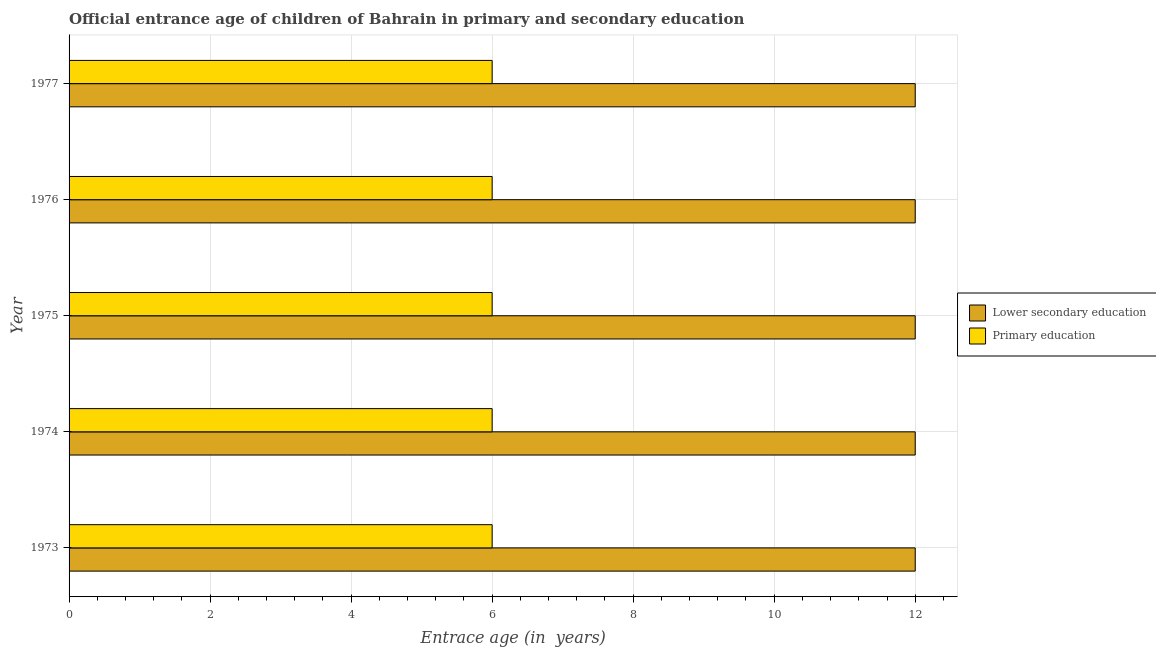How many groups of bars are there?
Your answer should be very brief. 5. Are the number of bars per tick equal to the number of legend labels?
Your response must be concise. Yes. Are the number of bars on each tick of the Y-axis equal?
Make the answer very short. Yes. How many bars are there on the 4th tick from the top?
Give a very brief answer. 2. How many bars are there on the 1st tick from the bottom?
Give a very brief answer. 2. What is the label of the 5th group of bars from the top?
Your answer should be very brief. 1973. Across all years, what is the maximum entrance age of children in lower secondary education?
Offer a terse response. 12. Across all years, what is the minimum entrance age of children in lower secondary education?
Offer a very short reply. 12. In which year was the entrance age of chiildren in primary education minimum?
Your response must be concise. 1973. What is the total entrance age of children in lower secondary education in the graph?
Your answer should be very brief. 60. What is the difference between the entrance age of children in lower secondary education in 1976 and the entrance age of chiildren in primary education in 1974?
Provide a succinct answer. 6. In the year 1974, what is the difference between the entrance age of chiildren in primary education and entrance age of children in lower secondary education?
Your answer should be very brief. -6. What is the ratio of the entrance age of chiildren in primary education in 1974 to that in 1977?
Offer a terse response. 1. Is the entrance age of chiildren in primary education in 1975 less than that in 1976?
Offer a very short reply. No. Is the difference between the entrance age of children in lower secondary education in 1973 and 1976 greater than the difference between the entrance age of chiildren in primary education in 1973 and 1976?
Provide a succinct answer. No. In how many years, is the entrance age of children in lower secondary education greater than the average entrance age of children in lower secondary education taken over all years?
Keep it short and to the point. 0. Is the sum of the entrance age of children in lower secondary education in 1975 and 1976 greater than the maximum entrance age of chiildren in primary education across all years?
Your answer should be compact. Yes. What does the 2nd bar from the top in 1974 represents?
Offer a very short reply. Lower secondary education. What does the 1st bar from the bottom in 1977 represents?
Provide a short and direct response. Lower secondary education. Are all the bars in the graph horizontal?
Offer a terse response. Yes. Where does the legend appear in the graph?
Your response must be concise. Center right. What is the title of the graph?
Offer a terse response. Official entrance age of children of Bahrain in primary and secondary education. Does "Methane" appear as one of the legend labels in the graph?
Offer a very short reply. No. What is the label or title of the X-axis?
Keep it short and to the point. Entrace age (in  years). What is the label or title of the Y-axis?
Your answer should be compact. Year. What is the Entrace age (in  years) of Lower secondary education in 1973?
Offer a terse response. 12. What is the Entrace age (in  years) of Primary education in 1973?
Offer a terse response. 6. What is the Entrace age (in  years) in Lower secondary education in 1974?
Your answer should be very brief. 12. What is the Entrace age (in  years) in Lower secondary education in 1975?
Offer a terse response. 12. What is the Entrace age (in  years) in Primary education in 1976?
Provide a succinct answer. 6. What is the Entrace age (in  years) in Primary education in 1977?
Provide a succinct answer. 6. What is the total Entrace age (in  years) of Primary education in the graph?
Keep it short and to the point. 30. What is the difference between the Entrace age (in  years) in Lower secondary education in 1973 and that in 1974?
Ensure brevity in your answer.  0. What is the difference between the Entrace age (in  years) in Primary education in 1973 and that in 1975?
Your answer should be very brief. 0. What is the difference between the Entrace age (in  years) of Primary education in 1973 and that in 1976?
Your answer should be compact. 0. What is the difference between the Entrace age (in  years) in Lower secondary education in 1973 and that in 1977?
Keep it short and to the point. 0. What is the difference between the Entrace age (in  years) of Primary education in 1974 and that in 1975?
Give a very brief answer. 0. What is the difference between the Entrace age (in  years) in Primary education in 1974 and that in 1977?
Your answer should be compact. 0. What is the difference between the Entrace age (in  years) of Primary education in 1975 and that in 1976?
Keep it short and to the point. 0. What is the difference between the Entrace age (in  years) of Lower secondary education in 1975 and that in 1977?
Offer a terse response. 0. What is the difference between the Entrace age (in  years) in Primary education in 1975 and that in 1977?
Your response must be concise. 0. What is the difference between the Entrace age (in  years) in Primary education in 1976 and that in 1977?
Provide a short and direct response. 0. What is the difference between the Entrace age (in  years) in Lower secondary education in 1973 and the Entrace age (in  years) in Primary education in 1974?
Provide a succinct answer. 6. What is the difference between the Entrace age (in  years) of Lower secondary education in 1973 and the Entrace age (in  years) of Primary education in 1976?
Provide a succinct answer. 6. What is the difference between the Entrace age (in  years) of Lower secondary education in 1973 and the Entrace age (in  years) of Primary education in 1977?
Ensure brevity in your answer.  6. What is the difference between the Entrace age (in  years) in Lower secondary education in 1974 and the Entrace age (in  years) in Primary education in 1975?
Your answer should be very brief. 6. What is the difference between the Entrace age (in  years) in Lower secondary education in 1974 and the Entrace age (in  years) in Primary education in 1977?
Provide a succinct answer. 6. What is the difference between the Entrace age (in  years) of Lower secondary education in 1975 and the Entrace age (in  years) of Primary education in 1976?
Provide a succinct answer. 6. What is the difference between the Entrace age (in  years) in Lower secondary education in 1975 and the Entrace age (in  years) in Primary education in 1977?
Provide a short and direct response. 6. What is the difference between the Entrace age (in  years) of Lower secondary education in 1976 and the Entrace age (in  years) of Primary education in 1977?
Your answer should be compact. 6. What is the average Entrace age (in  years) of Lower secondary education per year?
Provide a short and direct response. 12. In the year 1974, what is the difference between the Entrace age (in  years) of Lower secondary education and Entrace age (in  years) of Primary education?
Give a very brief answer. 6. In the year 1975, what is the difference between the Entrace age (in  years) of Lower secondary education and Entrace age (in  years) of Primary education?
Make the answer very short. 6. What is the ratio of the Entrace age (in  years) of Primary education in 1973 to that in 1974?
Ensure brevity in your answer.  1. What is the ratio of the Entrace age (in  years) in Lower secondary education in 1973 to that in 1976?
Offer a very short reply. 1. What is the ratio of the Entrace age (in  years) in Primary education in 1973 to that in 1977?
Offer a very short reply. 1. What is the ratio of the Entrace age (in  years) in Lower secondary education in 1974 to that in 1976?
Your response must be concise. 1. What is the ratio of the Entrace age (in  years) of Primary education in 1974 to that in 1976?
Offer a very short reply. 1. What is the ratio of the Entrace age (in  years) of Lower secondary education in 1974 to that in 1977?
Provide a succinct answer. 1. What is the ratio of the Entrace age (in  years) in Lower secondary education in 1975 to that in 1976?
Provide a short and direct response. 1. What is the ratio of the Entrace age (in  years) in Lower secondary education in 1975 to that in 1977?
Make the answer very short. 1. What is the ratio of the Entrace age (in  years) of Lower secondary education in 1976 to that in 1977?
Make the answer very short. 1. What is the ratio of the Entrace age (in  years) in Primary education in 1976 to that in 1977?
Your answer should be very brief. 1. What is the difference between the highest and the second highest Entrace age (in  years) in Lower secondary education?
Keep it short and to the point. 0. What is the difference between the highest and the lowest Entrace age (in  years) of Lower secondary education?
Give a very brief answer. 0. What is the difference between the highest and the lowest Entrace age (in  years) of Primary education?
Your response must be concise. 0. 